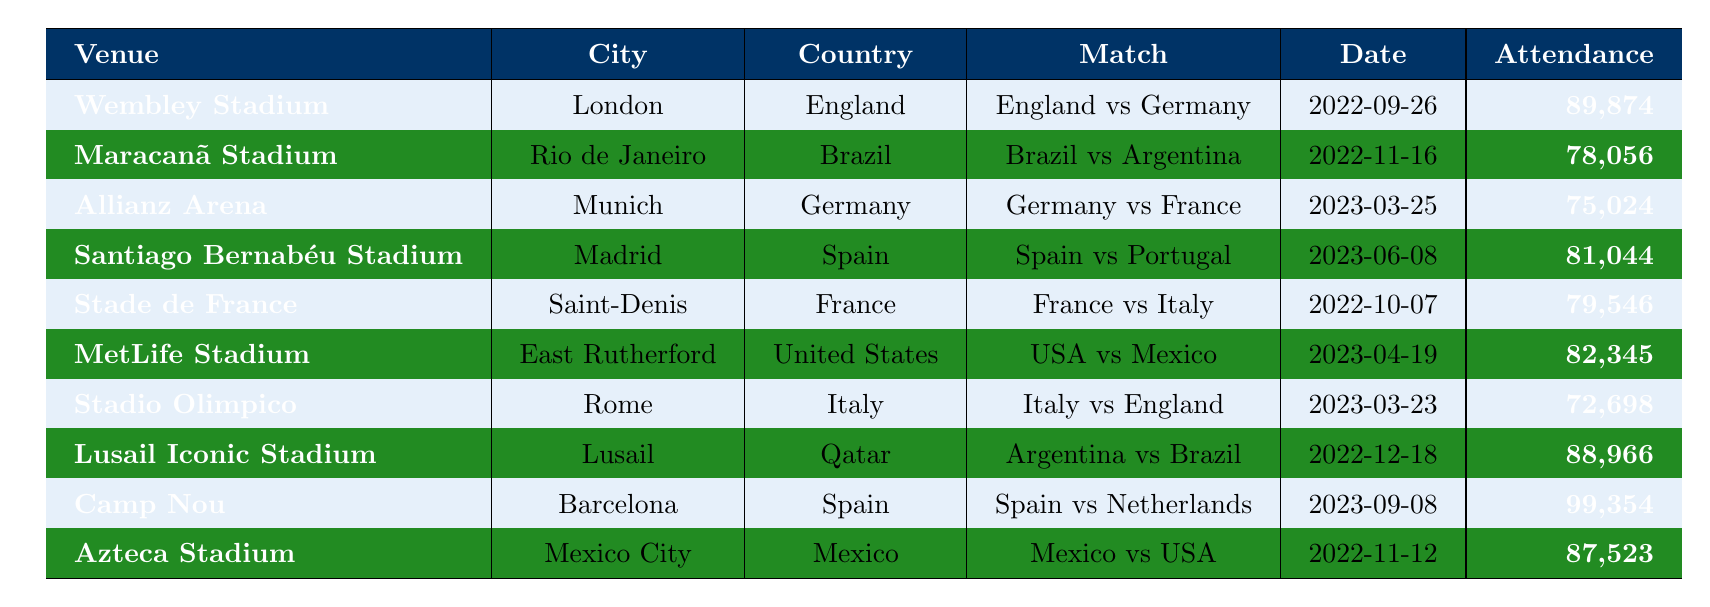What was the match with the highest attendance? The table shows the attendance figures for various matches. By comparing the attendance values, Camp Nou hosted the match with the highest attendance of 99,354.
Answer: Camp Nou Which country hosted the match between Brazil and Argentina? The match between Brazil and Argentina took place at Maracanã Stadium in Rio de Janeiro, Brazil.
Answer: Brazil How many matches had an attendance of over 80,000? By counting the attendances greater than 80,000 from the table, we identify the matches: Wembley Stadium, Lusail Iconic Stadium, MetLife Stadium, Santiago Bernabéu Stadium, and Camp Nou. This totals to five matches.
Answer: 5 What is the average attendance of all matches listed? To find the average, sum the attendances (89,874 + 78,056 + 75,024 + 81,044 + 79,546 + 82,345 + 72,698 + 88,966 + 99,354 + 87,523) to get  913,057, then divide by the number of matches (10). The average attendance is 91,305.7, which can be rounded to 91,306.
Answer: 91,306 Did Spain host more matches than Brazil in this table? Reviewing the table, Spain hosted two matches (Santiago Bernabéu Stadium and Camp Nou) while Brazil hosted one match (Maracanã Stadium). Therefore, Spain did host more matches than Brazil.
Answer: Yes What was the attendance difference between the highest and the lowest match? The highest attendance is 99,354 at Camp Nou, while the lowest is 72,698 at Stadio Olimpico. The difference is 99,354 - 72,698 = 26,656.
Answer: 26,656 Which venue in London had an international football match, and what was the attendance? The venue in London is Wembley Stadium, which hosted the match between England and Germany with an attendance of 89,874.
Answer: Wembley Stadium, 89,874 Was there a match held in Qatar, and if so, what was the attendance? Yes, the Lusail Iconic Stadium in Qatar hosted a match between Argentina and Brazil with an attendance of 88,966.
Answer: Yes, 88,966 What is the total attendance for matches held in Spain? The matches in Spain are at Santiago Bernabéu Stadium (81,044) and Camp Nou (99,354). Their total attendance is 81,044 + 99,354 = 180,398.
Answer: 180,398 Which two countries faced off in the match with the second highest attendance? The match with the second highest attendance is between Argentina and Brazil at Lusail Iconic Stadium, with 88,966 attendees.
Answer: Argentina and Brazil 